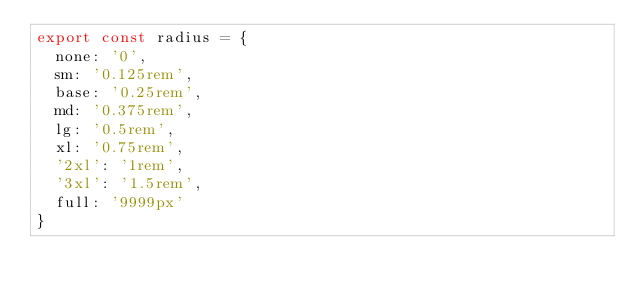<code> <loc_0><loc_0><loc_500><loc_500><_TypeScript_>export const radius = {
  none: '0',
  sm: '0.125rem',
  base: '0.25rem',
  md: '0.375rem',
  lg: '0.5rem',
  xl: '0.75rem',
  '2xl': '1rem',
  '3xl': '1.5rem',
  full: '9999px'
}
</code> 